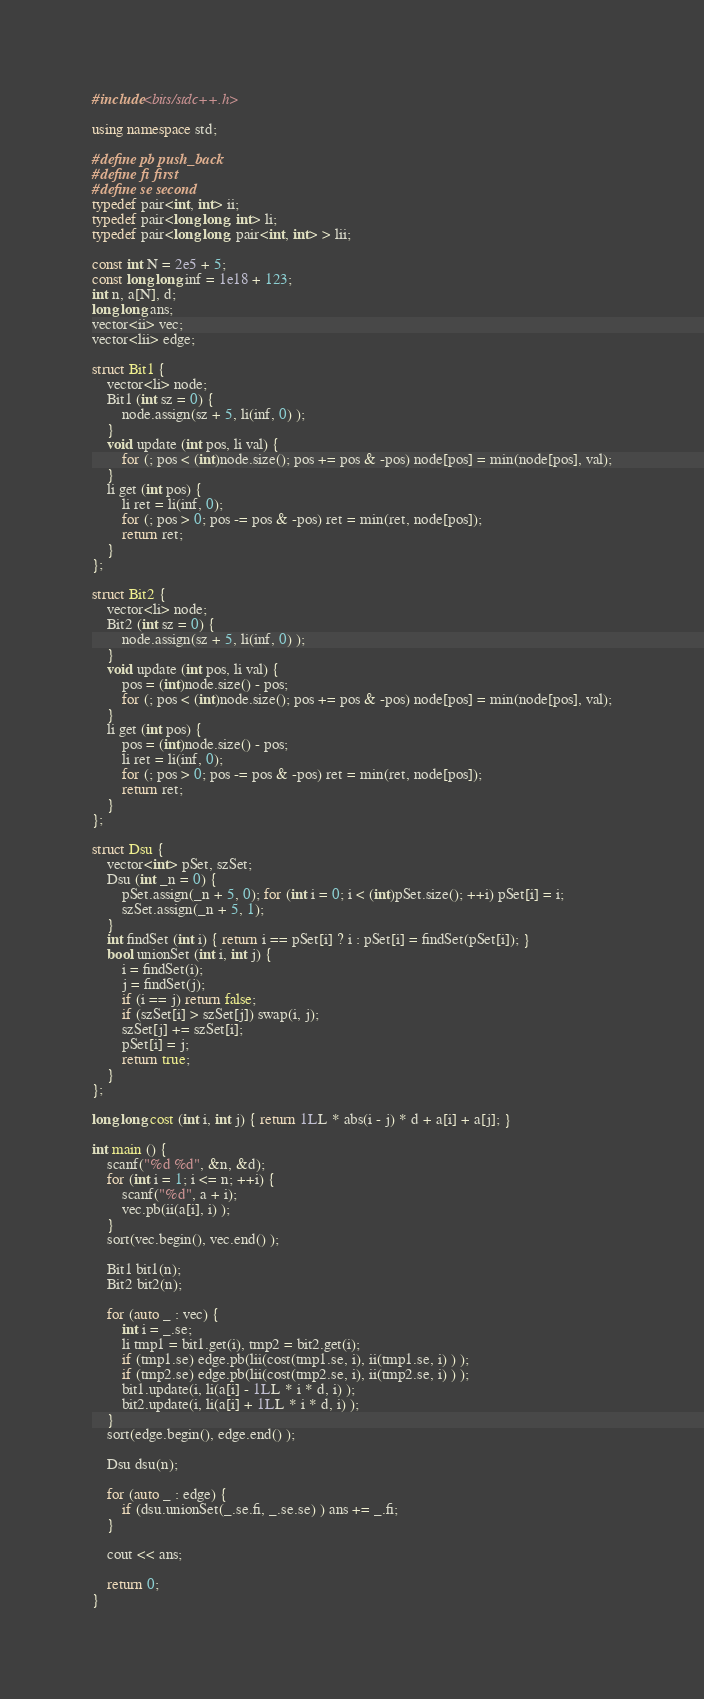Convert code to text. <code><loc_0><loc_0><loc_500><loc_500><_C++_>#include<bits/stdc++.h>

using namespace std;

#define pb push_back
#define fi first
#define se second
typedef pair<int, int> ii;
typedef pair<long long, int> li;
typedef pair<long long, pair<int, int> > lii;

const int N = 2e5 + 5;
const long long inf = 1e18 + 123;
int n, a[N], d;
long long ans;
vector<ii> vec;
vector<lii> edge;

struct Bit1 {
    vector<li> node;
    Bit1 (int sz = 0) {
        node.assign(sz + 5, li(inf, 0) );
    }
    void update (int pos, li val) {
        for (; pos < (int)node.size(); pos += pos & -pos) node[pos] = min(node[pos], val);
    }
    li get (int pos) {
        li ret = li(inf, 0);
        for (; pos > 0; pos -= pos & -pos) ret = min(ret, node[pos]);
        return ret;
    }
};

struct Bit2 {
    vector<li> node;
    Bit2 (int sz = 0) {
        node.assign(sz + 5, li(inf, 0) );
    }
    void update (int pos, li val) {
        pos = (int)node.size() - pos;
        for (; pos < (int)node.size(); pos += pos & -pos) node[pos] = min(node[pos], val);
    }
    li get (int pos) {
        pos = (int)node.size() - pos;
        li ret = li(inf, 0);
        for (; pos > 0; pos -= pos & -pos) ret = min(ret, node[pos]);
        return ret;
    }
};

struct Dsu {
    vector<int> pSet, szSet;
    Dsu (int _n = 0) {
        pSet.assign(_n + 5, 0); for (int i = 0; i < (int)pSet.size(); ++i) pSet[i] = i;
        szSet.assign(_n + 5, 1);
    }
    int findSet (int i) { return i == pSet[i] ? i : pSet[i] = findSet(pSet[i]); }
    bool unionSet (int i, int j) {
        i = findSet(i);
        j = findSet(j);
        if (i == j) return false;
        if (szSet[i] > szSet[j]) swap(i, j);
        szSet[j] += szSet[i];
        pSet[i] = j;
        return true;
    }
};

long long cost (int i, int j) { return 1LL * abs(i - j) * d + a[i] + a[j]; }

int main () {
    scanf("%d %d", &n, &d);
    for (int i = 1; i <= n; ++i) {
        scanf("%d", a + i);
        vec.pb(ii(a[i], i) );
    }
    sort(vec.begin(), vec.end() );

    Bit1 bit1(n);
    Bit2 bit2(n);

    for (auto _ : vec) {
        int i = _.se;
        li tmp1 = bit1.get(i), tmp2 = bit2.get(i);
        if (tmp1.se) edge.pb(lii(cost(tmp1.se, i), ii(tmp1.se, i) ) );
        if (tmp2.se) edge.pb(lii(cost(tmp2.se, i), ii(tmp2.se, i) ) );
        bit1.update(i, li(a[i] - 1LL * i * d, i) );
        bit2.update(i, li(a[i] + 1LL * i * d, i) );
    }
    sort(edge.begin(), edge.end() );

    Dsu dsu(n);

    for (auto _ : edge) {
        if (dsu.unionSet(_.se.fi, _.se.se) ) ans += _.fi;
    }

    cout << ans;

    return 0;
}
</code> 